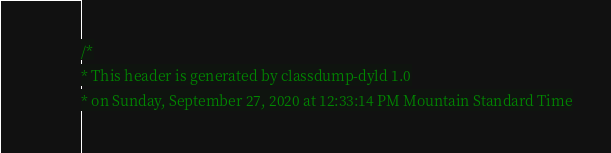<code> <loc_0><loc_0><loc_500><loc_500><_C_>/*
* This header is generated by classdump-dyld 1.0
* on Sunday, September 27, 2020 at 12:33:14 PM Mountain Standard Time</code> 